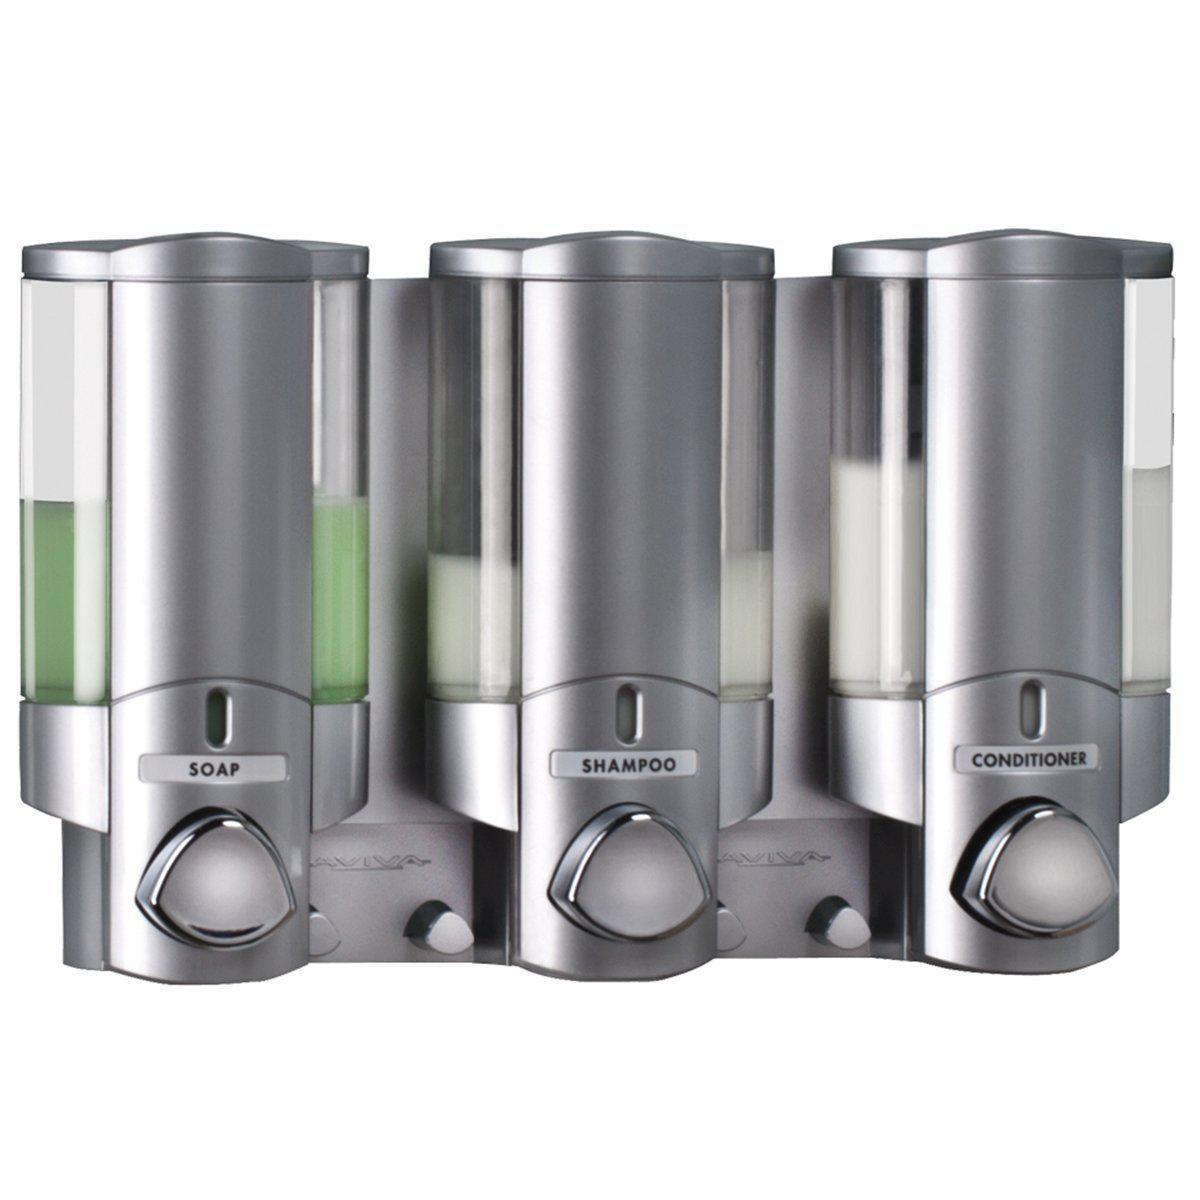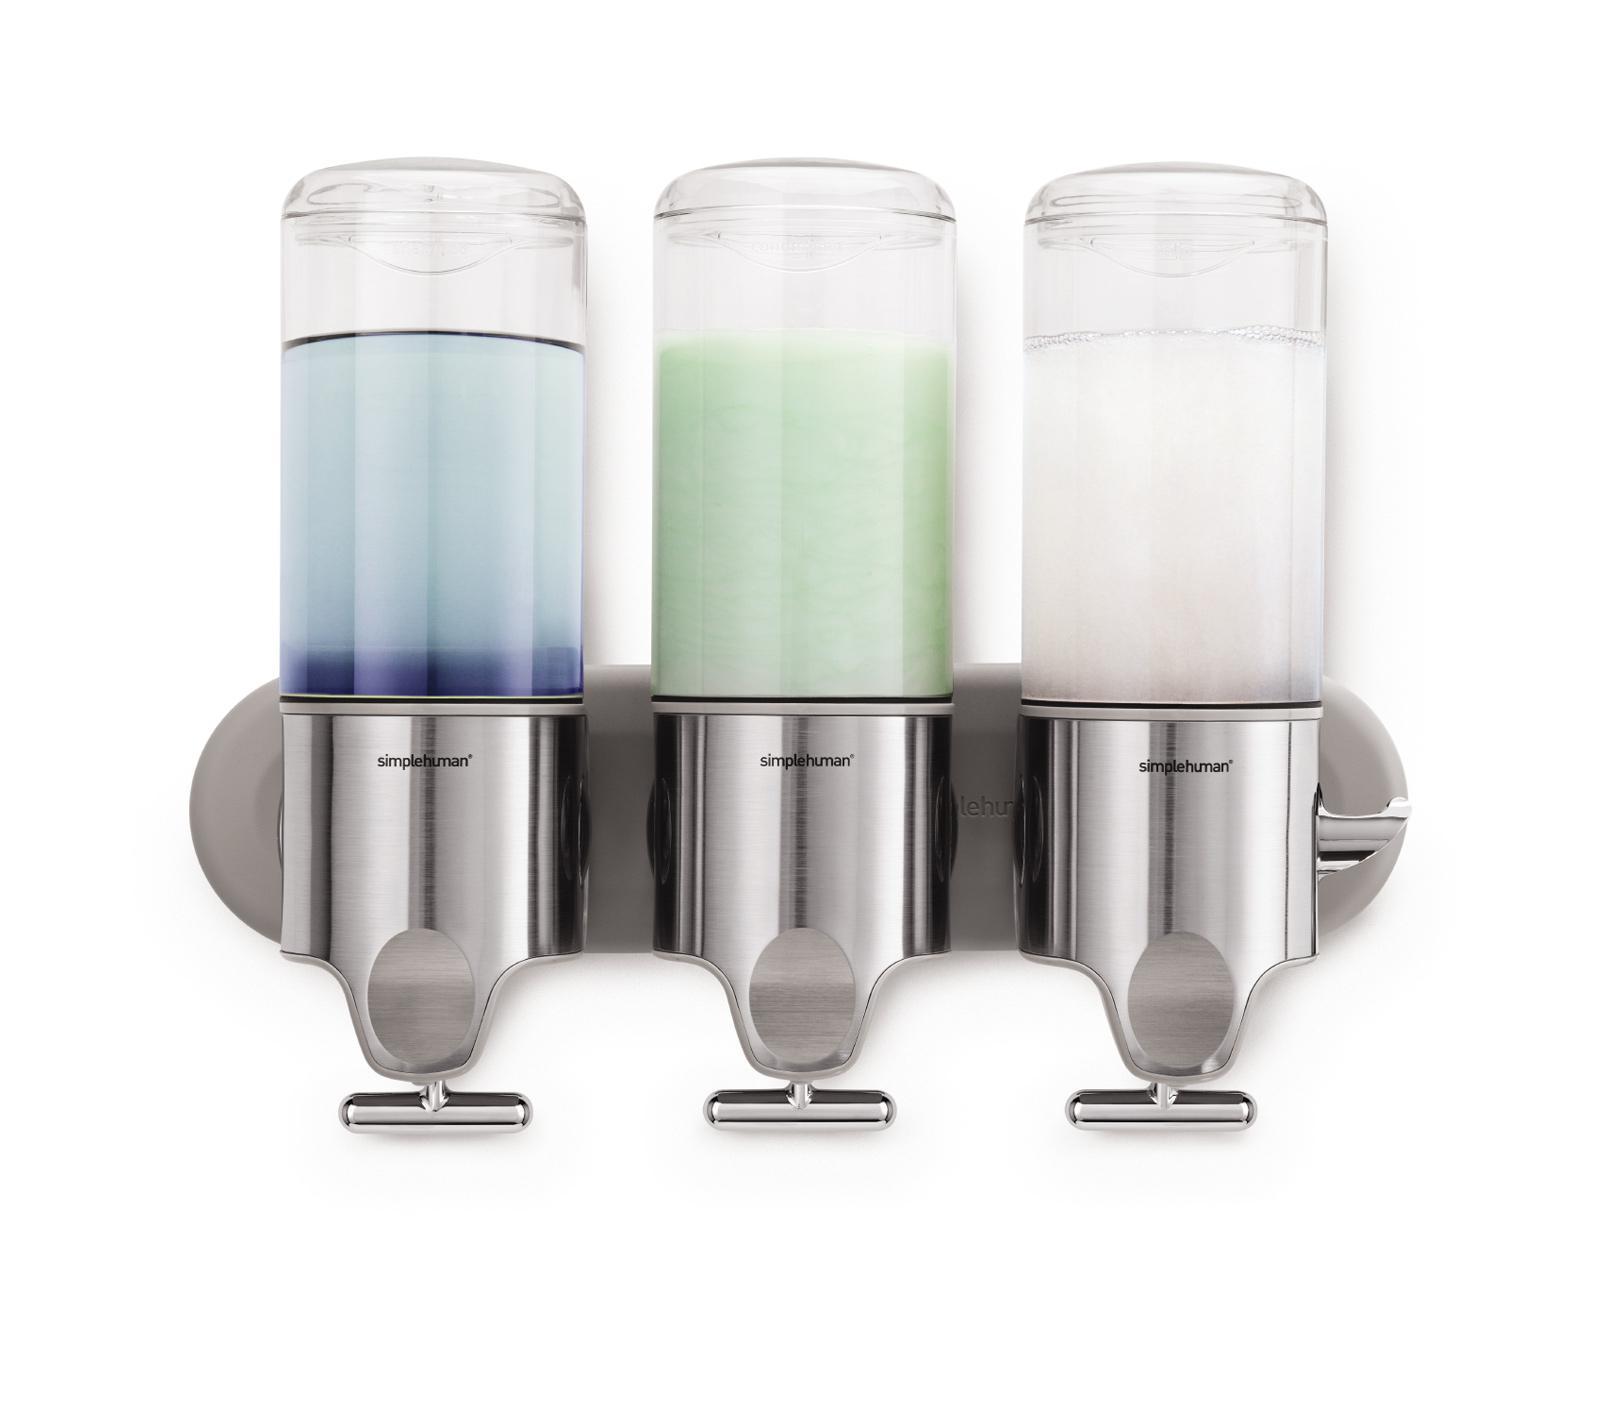The first image is the image on the left, the second image is the image on the right. Considering the images on both sides, is "One image shows a cylindrical dispenser with a pump top and nozzle." valid? Answer yes or no. No. 